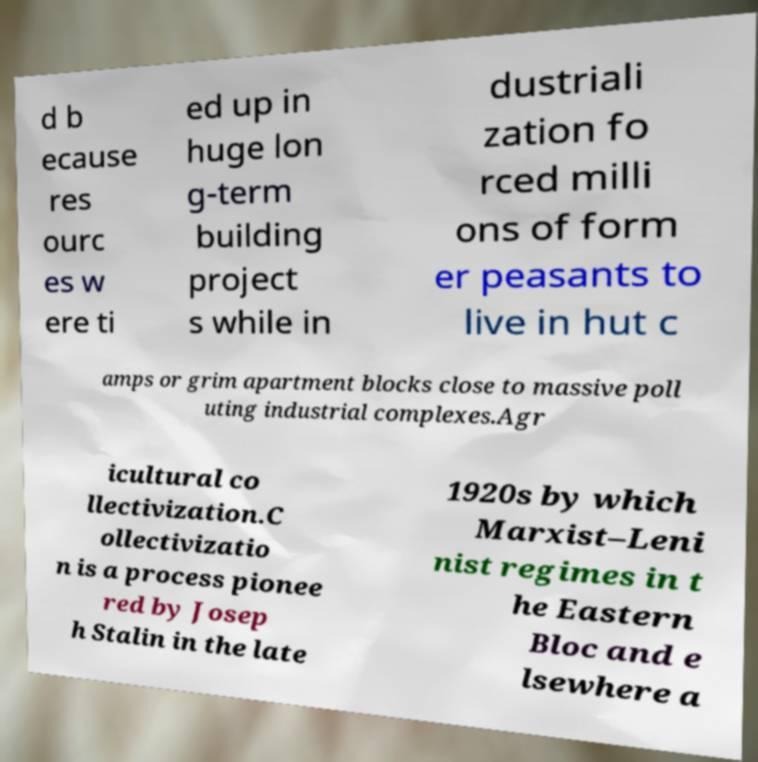What messages or text are displayed in this image? I need them in a readable, typed format. d b ecause res ourc es w ere ti ed up in huge lon g-term building project s while in dustriali zation fo rced milli ons of form er peasants to live in hut c amps or grim apartment blocks close to massive poll uting industrial complexes.Agr icultural co llectivization.C ollectivizatio n is a process pionee red by Josep h Stalin in the late 1920s by which Marxist–Leni nist regimes in t he Eastern Bloc and e lsewhere a 